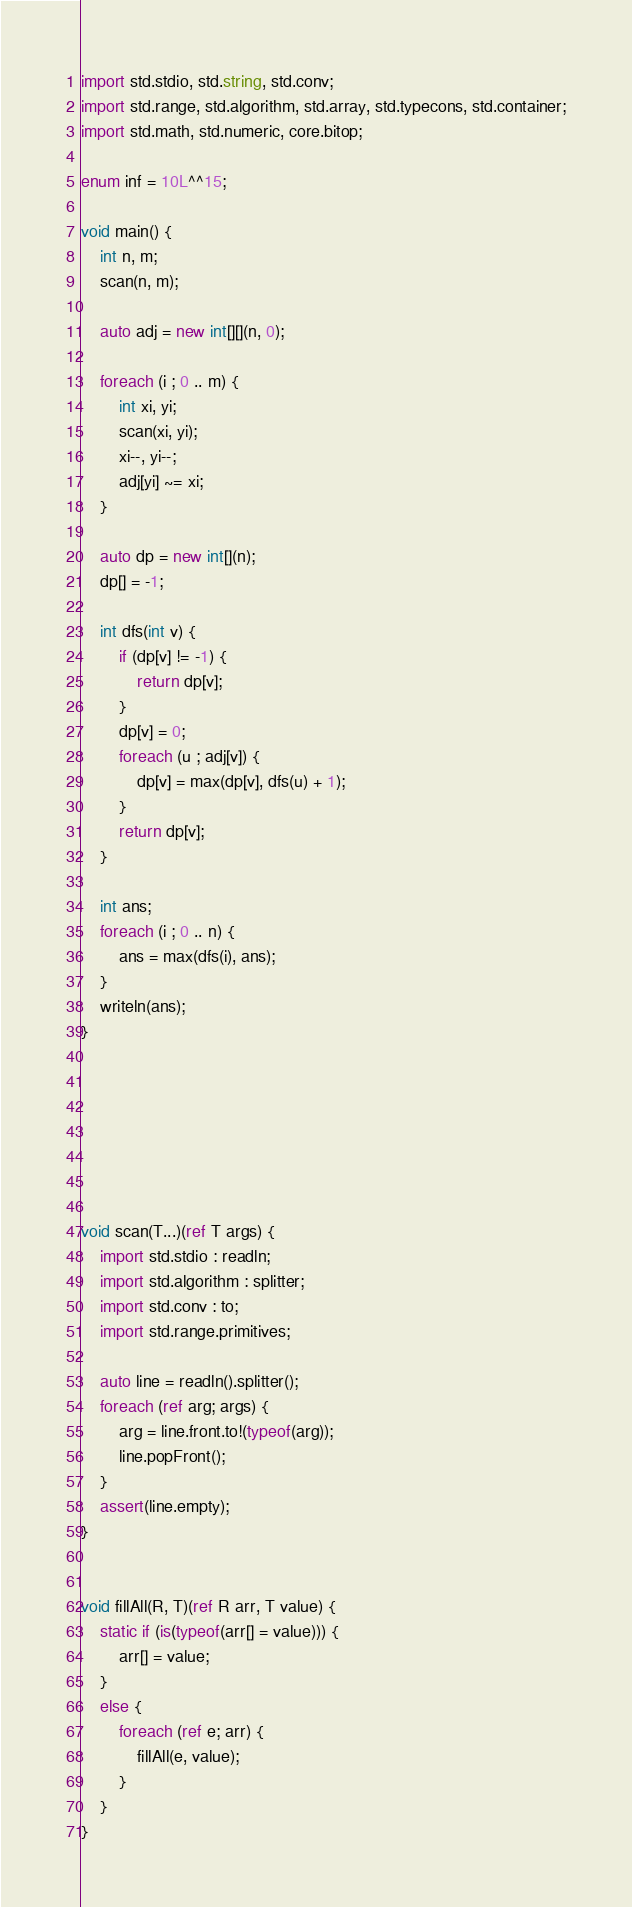<code> <loc_0><loc_0><loc_500><loc_500><_D_>import std.stdio, std.string, std.conv;
import std.range, std.algorithm, std.array, std.typecons, std.container;
import std.math, std.numeric, core.bitop;

enum inf = 10L^^15;

void main() {
    int n, m;
    scan(n, m);

    auto adj = new int[][](n, 0);

    foreach (i ; 0 .. m) {
        int xi, yi;
        scan(xi, yi);
        xi--, yi--;
        adj[yi] ~= xi;
    }

    auto dp = new int[](n);
    dp[] = -1;

    int dfs(int v) {
        if (dp[v] != -1) {
            return dp[v];
        }
        dp[v] = 0;
        foreach (u ; adj[v]) {
            dp[v] = max(dp[v], dfs(u) + 1);
        }
        return dp[v];
    }

    int ans;
    foreach (i ; 0 .. n) {
        ans = max(dfs(i), ans);
    }
    writeln(ans);
}







void scan(T...)(ref T args) {
    import std.stdio : readln;
    import std.algorithm : splitter;
    import std.conv : to;
    import std.range.primitives;

    auto line = readln().splitter();
    foreach (ref arg; args) {
        arg = line.front.to!(typeof(arg));
        line.popFront();
    }
    assert(line.empty);
}


void fillAll(R, T)(ref R arr, T value) {
    static if (is(typeof(arr[] = value))) {
        arr[] = value;
    }
    else {
        foreach (ref e; arr) {
            fillAll(e, value);
        }
    }
}</code> 